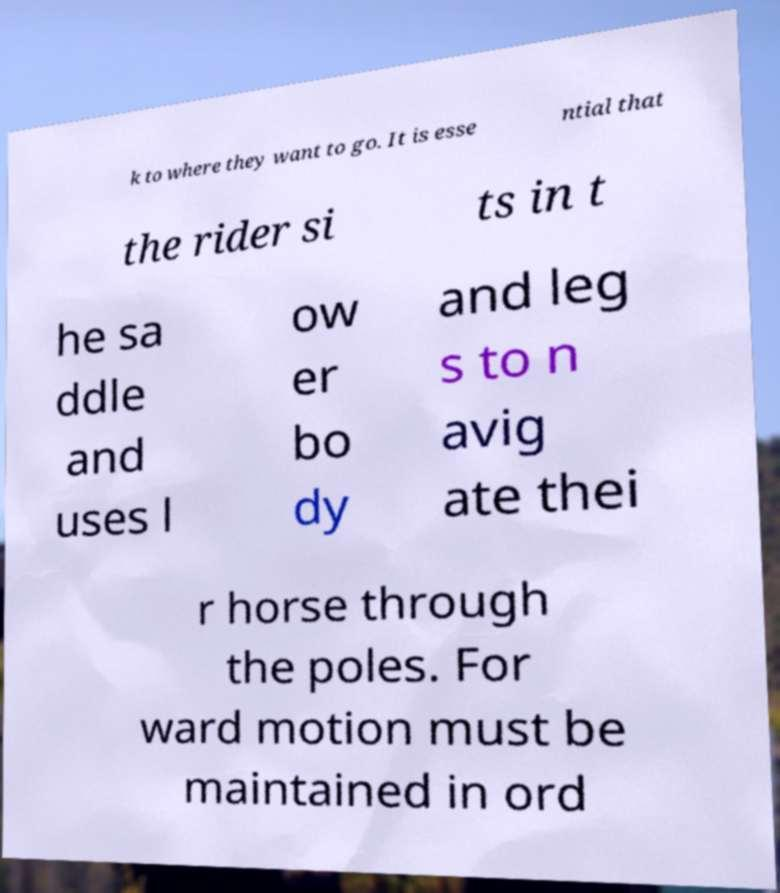There's text embedded in this image that I need extracted. Can you transcribe it verbatim? k to where they want to go. It is esse ntial that the rider si ts in t he sa ddle and uses l ow er bo dy and leg s to n avig ate thei r horse through the poles. For ward motion must be maintained in ord 